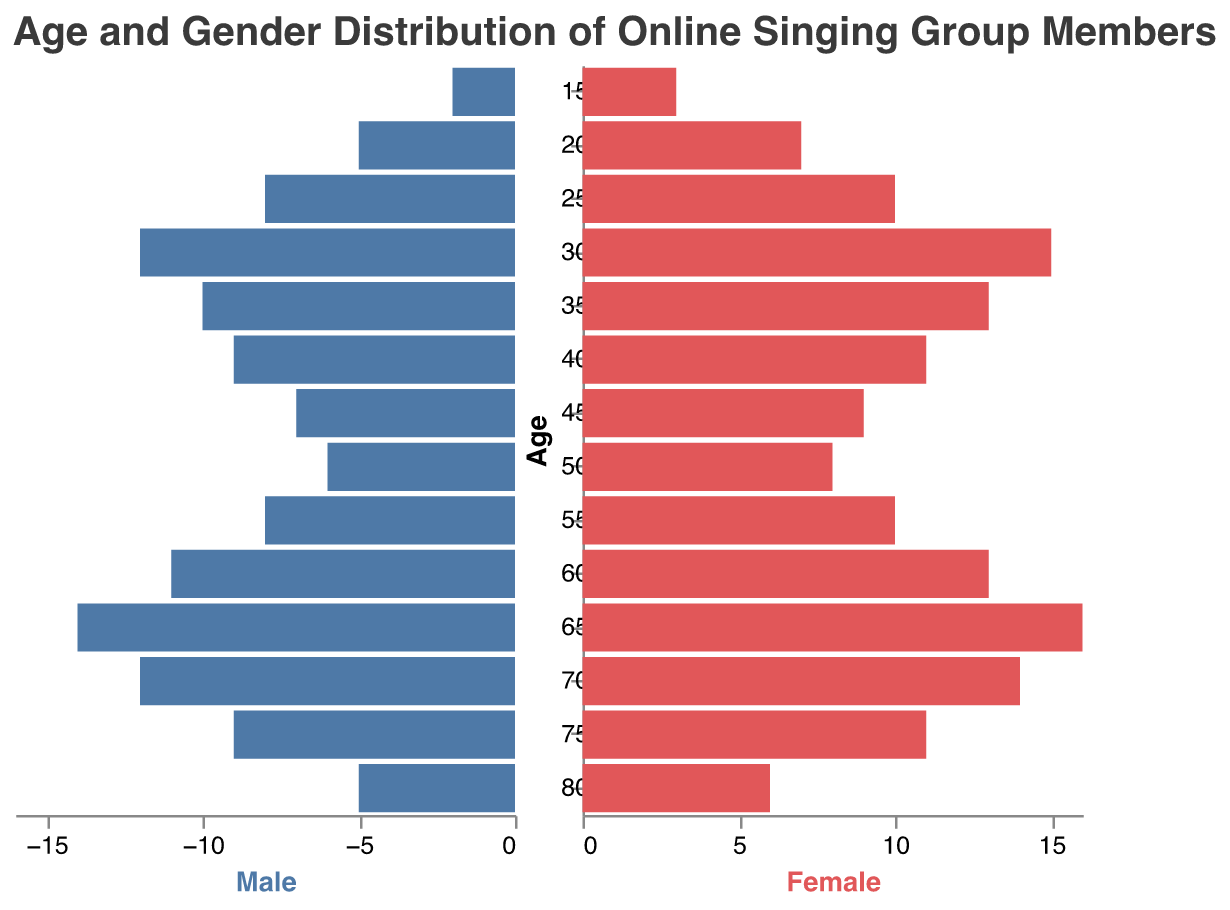What is the age group with the highest number of female members? The age group with the highest number of female members will be the one with the longest bar extending to the right on the Female side. The data shown in the figure indicates that the "65-69" age group has the longest bar.
Answer: 65-69 How many males are in the age group 30-34? The count of male members in the age group 30-34 can be found by looking at the height of the bar extending to the left under this age group on the Male side. It shows 12 males.
Answer: 12 What is the total number of members in the age group 20-24? To find the total number of members in the age group 20-24, add the number of males and females in this group. From the figure, there are 5 males and 7 females, so 5 + 7 = 12 members.
Answer: 12 Which gender has more members in the age group 45-49, and by how many? Compare the lengths of the bars for males and females in the age group 45-49. The figure shows 7 males and 9 females. The difference is 9 - 7 = 2.
Answer: Females by 2 How does the number of members aged 60-64 compare to those aged 15-19? To compare the total number of members, add the number of males and females for both age groups. For 60-64, the total is 11 males + 13 females = 24. For 15-19, the total is 2 males + 3 females = 5. So, the 60-64 group has 24 - 5 = 19 more members.
Answer: 19 more members in 60-64 What is the median age group for the male members? To find the median age group for male members, list the number of males by age groups, order the numbers, and find the middle value. The age groups listed are: 2, 5, 7, 8, 8, 9, 9, 10, 11, 12, 12, 14. The middle value between 10 and 11 is 10.5, so the median age group is approximately between 35-39 and 40-44.
Answer: 35-44 Which age group has an equal number of male and female members? An age group with equal male and female members will have bars of the same length for both males and females. From the figure, no age group shows equal lengths exactly.
Answer: None How many total members are in the age group 70-74? Add the number of males and females in the age group 70-74. There are 12 males and 14 females, so 12 + 14 = 26 members.
Answer: 26 Which gender has more members in the age group 25-29, and by how many? Compare the lengths of the bars for males and females in the age group 25-29. The figure shows 8 males and 10 females. The difference is 10 - 8 = 2.
Answer: Females by 2 What is the overall trend in the number of male members across different age groups? Observe the general pattern in the lengths of bars representing male members from the youngest to the oldest age group. The bars increase in height up to the age group 65-69 and then slightly decline.
Answer: Increasing to 65-69, then decline 